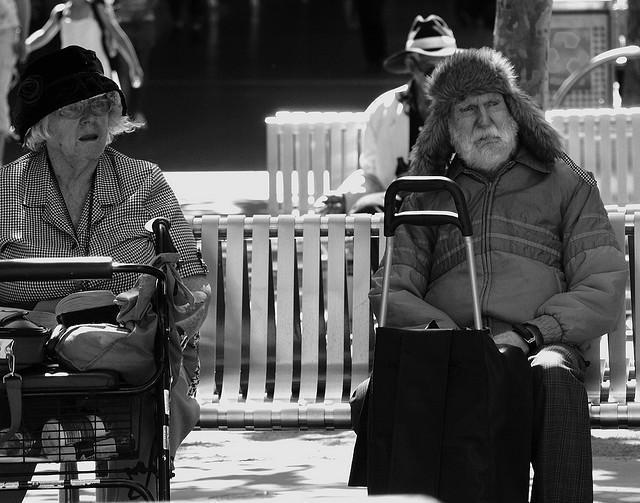How many people are wearing hats?
Give a very brief answer. 3. How many benches can be seen?
Give a very brief answer. 2. How many people can you see?
Give a very brief answer. 4. How many cows are facing the camera?
Give a very brief answer. 0. 